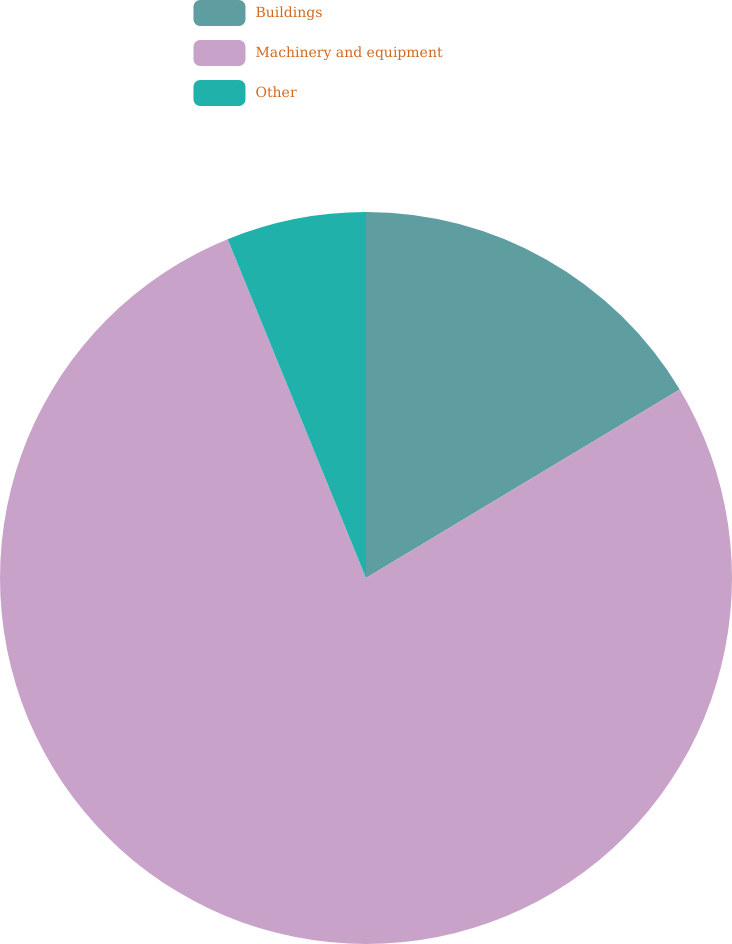Convert chart to OTSL. <chart><loc_0><loc_0><loc_500><loc_500><pie_chart><fcel>Buildings<fcel>Machinery and equipment<fcel>Other<nl><fcel>16.39%<fcel>77.44%<fcel>6.17%<nl></chart> 